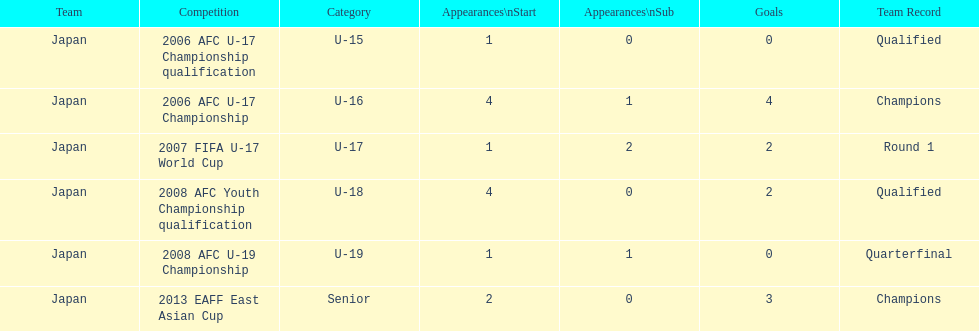At which place did japan achieve a mere four goals? 2006 AFC U-17 Championship. 